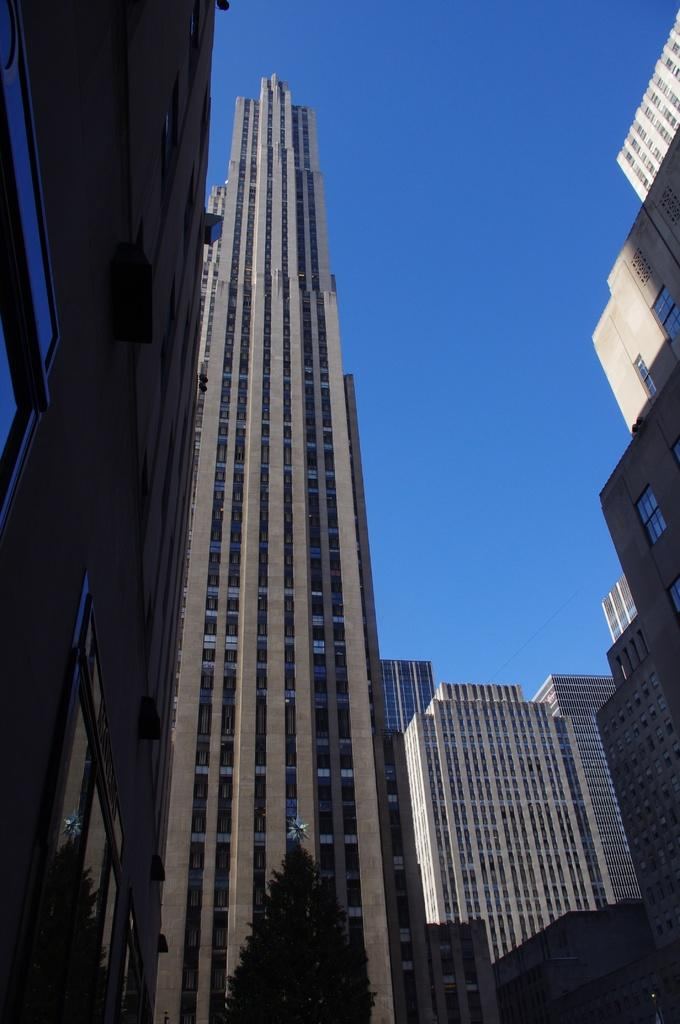What type of structures are present in the image? There are tower buildings in the image. What other elements can be seen in the image besides the buildings? There are trees in the image. What is visible in the sky in the image? There are clouds visible in the sky. Can you describe the person sitting on the cream-colored chair in the image? There is no person or cream-colored chair present in the image. 